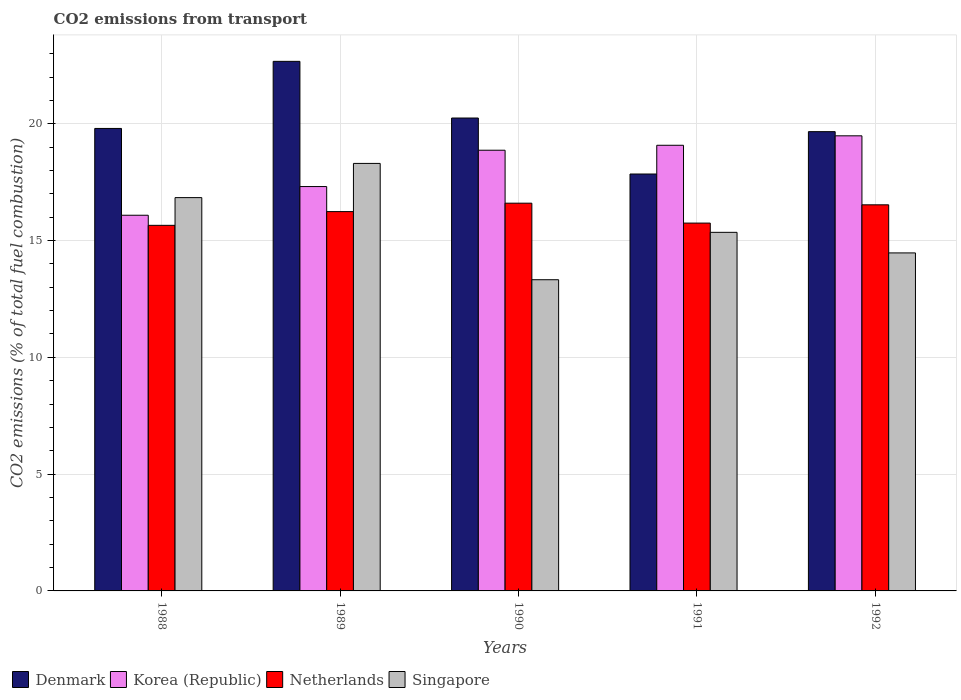How many different coloured bars are there?
Offer a very short reply. 4. How many groups of bars are there?
Your answer should be compact. 5. How many bars are there on the 1st tick from the right?
Ensure brevity in your answer.  4. What is the total CO2 emitted in Singapore in 1989?
Your answer should be compact. 18.3. Across all years, what is the maximum total CO2 emitted in Denmark?
Make the answer very short. 22.67. Across all years, what is the minimum total CO2 emitted in Korea (Republic)?
Your response must be concise. 16.08. In which year was the total CO2 emitted in Singapore minimum?
Keep it short and to the point. 1990. What is the total total CO2 emitted in Netherlands in the graph?
Keep it short and to the point. 80.76. What is the difference between the total CO2 emitted in Korea (Republic) in 1988 and that in 1991?
Offer a terse response. -3. What is the difference between the total CO2 emitted in Korea (Republic) in 1992 and the total CO2 emitted in Netherlands in 1991?
Offer a terse response. 3.74. What is the average total CO2 emitted in Singapore per year?
Ensure brevity in your answer.  15.66. In the year 1989, what is the difference between the total CO2 emitted in Denmark and total CO2 emitted in Singapore?
Make the answer very short. 4.37. In how many years, is the total CO2 emitted in Korea (Republic) greater than 21?
Provide a short and direct response. 0. What is the ratio of the total CO2 emitted in Singapore in 1991 to that in 1992?
Ensure brevity in your answer.  1.06. Is the difference between the total CO2 emitted in Denmark in 1989 and 1991 greater than the difference between the total CO2 emitted in Singapore in 1989 and 1991?
Your answer should be very brief. Yes. What is the difference between the highest and the second highest total CO2 emitted in Korea (Republic)?
Give a very brief answer. 0.4. What is the difference between the highest and the lowest total CO2 emitted in Korea (Republic)?
Give a very brief answer. 3.4. In how many years, is the total CO2 emitted in Denmark greater than the average total CO2 emitted in Denmark taken over all years?
Offer a very short reply. 2. Is it the case that in every year, the sum of the total CO2 emitted in Denmark and total CO2 emitted in Netherlands is greater than the sum of total CO2 emitted in Singapore and total CO2 emitted in Korea (Republic)?
Provide a short and direct response. No. What does the 1st bar from the right in 1991 represents?
Your response must be concise. Singapore. Is it the case that in every year, the sum of the total CO2 emitted in Netherlands and total CO2 emitted in Korea (Republic) is greater than the total CO2 emitted in Singapore?
Your response must be concise. Yes. How many bars are there?
Your answer should be compact. 20. What is the difference between two consecutive major ticks on the Y-axis?
Your answer should be very brief. 5. Does the graph contain grids?
Ensure brevity in your answer.  Yes. Where does the legend appear in the graph?
Offer a very short reply. Bottom left. How are the legend labels stacked?
Your answer should be very brief. Horizontal. What is the title of the graph?
Offer a terse response. CO2 emissions from transport. Does "Hungary" appear as one of the legend labels in the graph?
Your response must be concise. No. What is the label or title of the X-axis?
Offer a very short reply. Years. What is the label or title of the Y-axis?
Your response must be concise. CO2 emissions (% of total fuel combustion). What is the CO2 emissions (% of total fuel combustion) in Denmark in 1988?
Your answer should be compact. 19.8. What is the CO2 emissions (% of total fuel combustion) of Korea (Republic) in 1988?
Ensure brevity in your answer.  16.08. What is the CO2 emissions (% of total fuel combustion) of Netherlands in 1988?
Offer a terse response. 15.65. What is the CO2 emissions (% of total fuel combustion) of Singapore in 1988?
Ensure brevity in your answer.  16.84. What is the CO2 emissions (% of total fuel combustion) of Denmark in 1989?
Make the answer very short. 22.67. What is the CO2 emissions (% of total fuel combustion) of Korea (Republic) in 1989?
Ensure brevity in your answer.  17.31. What is the CO2 emissions (% of total fuel combustion) in Netherlands in 1989?
Give a very brief answer. 16.24. What is the CO2 emissions (% of total fuel combustion) in Singapore in 1989?
Provide a short and direct response. 18.3. What is the CO2 emissions (% of total fuel combustion) in Denmark in 1990?
Give a very brief answer. 20.24. What is the CO2 emissions (% of total fuel combustion) of Korea (Republic) in 1990?
Make the answer very short. 18.87. What is the CO2 emissions (% of total fuel combustion) in Netherlands in 1990?
Your answer should be very brief. 16.6. What is the CO2 emissions (% of total fuel combustion) of Singapore in 1990?
Offer a terse response. 13.32. What is the CO2 emissions (% of total fuel combustion) of Denmark in 1991?
Give a very brief answer. 17.85. What is the CO2 emissions (% of total fuel combustion) of Korea (Republic) in 1991?
Keep it short and to the point. 19.08. What is the CO2 emissions (% of total fuel combustion) in Netherlands in 1991?
Offer a terse response. 15.75. What is the CO2 emissions (% of total fuel combustion) of Singapore in 1991?
Provide a succinct answer. 15.35. What is the CO2 emissions (% of total fuel combustion) in Denmark in 1992?
Make the answer very short. 19.66. What is the CO2 emissions (% of total fuel combustion) of Korea (Republic) in 1992?
Offer a very short reply. 19.48. What is the CO2 emissions (% of total fuel combustion) of Netherlands in 1992?
Ensure brevity in your answer.  16.53. What is the CO2 emissions (% of total fuel combustion) in Singapore in 1992?
Offer a terse response. 14.47. Across all years, what is the maximum CO2 emissions (% of total fuel combustion) of Denmark?
Your response must be concise. 22.67. Across all years, what is the maximum CO2 emissions (% of total fuel combustion) in Korea (Republic)?
Provide a succinct answer. 19.48. Across all years, what is the maximum CO2 emissions (% of total fuel combustion) in Netherlands?
Keep it short and to the point. 16.6. Across all years, what is the maximum CO2 emissions (% of total fuel combustion) of Singapore?
Your answer should be compact. 18.3. Across all years, what is the minimum CO2 emissions (% of total fuel combustion) of Denmark?
Make the answer very short. 17.85. Across all years, what is the minimum CO2 emissions (% of total fuel combustion) in Korea (Republic)?
Make the answer very short. 16.08. Across all years, what is the minimum CO2 emissions (% of total fuel combustion) in Netherlands?
Your answer should be very brief. 15.65. Across all years, what is the minimum CO2 emissions (% of total fuel combustion) in Singapore?
Make the answer very short. 13.32. What is the total CO2 emissions (% of total fuel combustion) of Denmark in the graph?
Ensure brevity in your answer.  100.22. What is the total CO2 emissions (% of total fuel combustion) in Korea (Republic) in the graph?
Keep it short and to the point. 90.82. What is the total CO2 emissions (% of total fuel combustion) in Netherlands in the graph?
Offer a terse response. 80.76. What is the total CO2 emissions (% of total fuel combustion) of Singapore in the graph?
Ensure brevity in your answer.  78.28. What is the difference between the CO2 emissions (% of total fuel combustion) in Denmark in 1988 and that in 1989?
Your answer should be compact. -2.87. What is the difference between the CO2 emissions (% of total fuel combustion) in Korea (Republic) in 1988 and that in 1989?
Ensure brevity in your answer.  -1.23. What is the difference between the CO2 emissions (% of total fuel combustion) in Netherlands in 1988 and that in 1989?
Your answer should be compact. -0.59. What is the difference between the CO2 emissions (% of total fuel combustion) in Singapore in 1988 and that in 1989?
Provide a short and direct response. -1.46. What is the difference between the CO2 emissions (% of total fuel combustion) of Denmark in 1988 and that in 1990?
Your response must be concise. -0.45. What is the difference between the CO2 emissions (% of total fuel combustion) of Korea (Republic) in 1988 and that in 1990?
Offer a terse response. -2.78. What is the difference between the CO2 emissions (% of total fuel combustion) of Netherlands in 1988 and that in 1990?
Your response must be concise. -0.95. What is the difference between the CO2 emissions (% of total fuel combustion) of Singapore in 1988 and that in 1990?
Offer a very short reply. 3.51. What is the difference between the CO2 emissions (% of total fuel combustion) in Denmark in 1988 and that in 1991?
Make the answer very short. 1.95. What is the difference between the CO2 emissions (% of total fuel combustion) in Korea (Republic) in 1988 and that in 1991?
Ensure brevity in your answer.  -3. What is the difference between the CO2 emissions (% of total fuel combustion) of Netherlands in 1988 and that in 1991?
Your answer should be compact. -0.1. What is the difference between the CO2 emissions (% of total fuel combustion) of Singapore in 1988 and that in 1991?
Your response must be concise. 1.49. What is the difference between the CO2 emissions (% of total fuel combustion) of Denmark in 1988 and that in 1992?
Offer a terse response. 0.14. What is the difference between the CO2 emissions (% of total fuel combustion) in Korea (Republic) in 1988 and that in 1992?
Your answer should be very brief. -3.4. What is the difference between the CO2 emissions (% of total fuel combustion) of Netherlands in 1988 and that in 1992?
Offer a terse response. -0.88. What is the difference between the CO2 emissions (% of total fuel combustion) in Singapore in 1988 and that in 1992?
Give a very brief answer. 2.37. What is the difference between the CO2 emissions (% of total fuel combustion) of Denmark in 1989 and that in 1990?
Make the answer very short. 2.43. What is the difference between the CO2 emissions (% of total fuel combustion) of Korea (Republic) in 1989 and that in 1990?
Ensure brevity in your answer.  -1.56. What is the difference between the CO2 emissions (% of total fuel combustion) in Netherlands in 1989 and that in 1990?
Offer a terse response. -0.36. What is the difference between the CO2 emissions (% of total fuel combustion) of Singapore in 1989 and that in 1990?
Make the answer very short. 4.98. What is the difference between the CO2 emissions (% of total fuel combustion) in Denmark in 1989 and that in 1991?
Provide a succinct answer. 4.82. What is the difference between the CO2 emissions (% of total fuel combustion) of Korea (Republic) in 1989 and that in 1991?
Ensure brevity in your answer.  -1.77. What is the difference between the CO2 emissions (% of total fuel combustion) in Netherlands in 1989 and that in 1991?
Offer a very short reply. 0.49. What is the difference between the CO2 emissions (% of total fuel combustion) of Singapore in 1989 and that in 1991?
Offer a terse response. 2.95. What is the difference between the CO2 emissions (% of total fuel combustion) of Denmark in 1989 and that in 1992?
Your answer should be very brief. 3.01. What is the difference between the CO2 emissions (% of total fuel combustion) in Korea (Republic) in 1989 and that in 1992?
Offer a terse response. -2.17. What is the difference between the CO2 emissions (% of total fuel combustion) in Netherlands in 1989 and that in 1992?
Keep it short and to the point. -0.29. What is the difference between the CO2 emissions (% of total fuel combustion) of Singapore in 1989 and that in 1992?
Ensure brevity in your answer.  3.83. What is the difference between the CO2 emissions (% of total fuel combustion) of Denmark in 1990 and that in 1991?
Provide a succinct answer. 2.4. What is the difference between the CO2 emissions (% of total fuel combustion) in Korea (Republic) in 1990 and that in 1991?
Provide a short and direct response. -0.21. What is the difference between the CO2 emissions (% of total fuel combustion) of Netherlands in 1990 and that in 1991?
Your answer should be very brief. 0.85. What is the difference between the CO2 emissions (% of total fuel combustion) in Singapore in 1990 and that in 1991?
Keep it short and to the point. -2.03. What is the difference between the CO2 emissions (% of total fuel combustion) of Denmark in 1990 and that in 1992?
Make the answer very short. 0.58. What is the difference between the CO2 emissions (% of total fuel combustion) in Korea (Republic) in 1990 and that in 1992?
Your response must be concise. -0.62. What is the difference between the CO2 emissions (% of total fuel combustion) of Netherlands in 1990 and that in 1992?
Keep it short and to the point. 0.07. What is the difference between the CO2 emissions (% of total fuel combustion) of Singapore in 1990 and that in 1992?
Keep it short and to the point. -1.15. What is the difference between the CO2 emissions (% of total fuel combustion) of Denmark in 1991 and that in 1992?
Provide a short and direct response. -1.81. What is the difference between the CO2 emissions (% of total fuel combustion) of Korea (Republic) in 1991 and that in 1992?
Keep it short and to the point. -0.4. What is the difference between the CO2 emissions (% of total fuel combustion) of Netherlands in 1991 and that in 1992?
Offer a terse response. -0.78. What is the difference between the CO2 emissions (% of total fuel combustion) in Singapore in 1991 and that in 1992?
Ensure brevity in your answer.  0.88. What is the difference between the CO2 emissions (% of total fuel combustion) of Denmark in 1988 and the CO2 emissions (% of total fuel combustion) of Korea (Republic) in 1989?
Ensure brevity in your answer.  2.49. What is the difference between the CO2 emissions (% of total fuel combustion) of Denmark in 1988 and the CO2 emissions (% of total fuel combustion) of Netherlands in 1989?
Your response must be concise. 3.56. What is the difference between the CO2 emissions (% of total fuel combustion) of Denmark in 1988 and the CO2 emissions (% of total fuel combustion) of Singapore in 1989?
Keep it short and to the point. 1.5. What is the difference between the CO2 emissions (% of total fuel combustion) in Korea (Republic) in 1988 and the CO2 emissions (% of total fuel combustion) in Netherlands in 1989?
Your answer should be very brief. -0.16. What is the difference between the CO2 emissions (% of total fuel combustion) in Korea (Republic) in 1988 and the CO2 emissions (% of total fuel combustion) in Singapore in 1989?
Ensure brevity in your answer.  -2.22. What is the difference between the CO2 emissions (% of total fuel combustion) of Netherlands in 1988 and the CO2 emissions (% of total fuel combustion) of Singapore in 1989?
Offer a very short reply. -2.65. What is the difference between the CO2 emissions (% of total fuel combustion) in Denmark in 1988 and the CO2 emissions (% of total fuel combustion) in Korea (Republic) in 1990?
Your answer should be compact. 0.93. What is the difference between the CO2 emissions (% of total fuel combustion) in Denmark in 1988 and the CO2 emissions (% of total fuel combustion) in Netherlands in 1990?
Keep it short and to the point. 3.2. What is the difference between the CO2 emissions (% of total fuel combustion) in Denmark in 1988 and the CO2 emissions (% of total fuel combustion) in Singapore in 1990?
Your answer should be very brief. 6.48. What is the difference between the CO2 emissions (% of total fuel combustion) of Korea (Republic) in 1988 and the CO2 emissions (% of total fuel combustion) of Netherlands in 1990?
Your response must be concise. -0.52. What is the difference between the CO2 emissions (% of total fuel combustion) of Korea (Republic) in 1988 and the CO2 emissions (% of total fuel combustion) of Singapore in 1990?
Make the answer very short. 2.76. What is the difference between the CO2 emissions (% of total fuel combustion) in Netherlands in 1988 and the CO2 emissions (% of total fuel combustion) in Singapore in 1990?
Make the answer very short. 2.33. What is the difference between the CO2 emissions (% of total fuel combustion) in Denmark in 1988 and the CO2 emissions (% of total fuel combustion) in Korea (Republic) in 1991?
Your answer should be very brief. 0.72. What is the difference between the CO2 emissions (% of total fuel combustion) of Denmark in 1988 and the CO2 emissions (% of total fuel combustion) of Netherlands in 1991?
Make the answer very short. 4.05. What is the difference between the CO2 emissions (% of total fuel combustion) of Denmark in 1988 and the CO2 emissions (% of total fuel combustion) of Singapore in 1991?
Keep it short and to the point. 4.45. What is the difference between the CO2 emissions (% of total fuel combustion) in Korea (Republic) in 1988 and the CO2 emissions (% of total fuel combustion) in Netherlands in 1991?
Keep it short and to the point. 0.34. What is the difference between the CO2 emissions (% of total fuel combustion) in Korea (Republic) in 1988 and the CO2 emissions (% of total fuel combustion) in Singapore in 1991?
Your answer should be very brief. 0.73. What is the difference between the CO2 emissions (% of total fuel combustion) in Netherlands in 1988 and the CO2 emissions (% of total fuel combustion) in Singapore in 1991?
Your answer should be very brief. 0.3. What is the difference between the CO2 emissions (% of total fuel combustion) in Denmark in 1988 and the CO2 emissions (% of total fuel combustion) in Korea (Republic) in 1992?
Provide a succinct answer. 0.32. What is the difference between the CO2 emissions (% of total fuel combustion) of Denmark in 1988 and the CO2 emissions (% of total fuel combustion) of Netherlands in 1992?
Offer a terse response. 3.27. What is the difference between the CO2 emissions (% of total fuel combustion) in Denmark in 1988 and the CO2 emissions (% of total fuel combustion) in Singapore in 1992?
Keep it short and to the point. 5.33. What is the difference between the CO2 emissions (% of total fuel combustion) of Korea (Republic) in 1988 and the CO2 emissions (% of total fuel combustion) of Netherlands in 1992?
Offer a terse response. -0.45. What is the difference between the CO2 emissions (% of total fuel combustion) in Korea (Republic) in 1988 and the CO2 emissions (% of total fuel combustion) in Singapore in 1992?
Offer a very short reply. 1.61. What is the difference between the CO2 emissions (% of total fuel combustion) of Netherlands in 1988 and the CO2 emissions (% of total fuel combustion) of Singapore in 1992?
Offer a very short reply. 1.18. What is the difference between the CO2 emissions (% of total fuel combustion) of Denmark in 1989 and the CO2 emissions (% of total fuel combustion) of Korea (Republic) in 1990?
Offer a terse response. 3.8. What is the difference between the CO2 emissions (% of total fuel combustion) of Denmark in 1989 and the CO2 emissions (% of total fuel combustion) of Netherlands in 1990?
Provide a short and direct response. 6.07. What is the difference between the CO2 emissions (% of total fuel combustion) of Denmark in 1989 and the CO2 emissions (% of total fuel combustion) of Singapore in 1990?
Provide a short and direct response. 9.35. What is the difference between the CO2 emissions (% of total fuel combustion) of Korea (Republic) in 1989 and the CO2 emissions (% of total fuel combustion) of Netherlands in 1990?
Ensure brevity in your answer.  0.71. What is the difference between the CO2 emissions (% of total fuel combustion) of Korea (Republic) in 1989 and the CO2 emissions (% of total fuel combustion) of Singapore in 1990?
Give a very brief answer. 3.99. What is the difference between the CO2 emissions (% of total fuel combustion) in Netherlands in 1989 and the CO2 emissions (% of total fuel combustion) in Singapore in 1990?
Give a very brief answer. 2.92. What is the difference between the CO2 emissions (% of total fuel combustion) in Denmark in 1989 and the CO2 emissions (% of total fuel combustion) in Korea (Republic) in 1991?
Make the answer very short. 3.59. What is the difference between the CO2 emissions (% of total fuel combustion) of Denmark in 1989 and the CO2 emissions (% of total fuel combustion) of Netherlands in 1991?
Your answer should be very brief. 6.92. What is the difference between the CO2 emissions (% of total fuel combustion) of Denmark in 1989 and the CO2 emissions (% of total fuel combustion) of Singapore in 1991?
Your answer should be very brief. 7.32. What is the difference between the CO2 emissions (% of total fuel combustion) in Korea (Republic) in 1989 and the CO2 emissions (% of total fuel combustion) in Netherlands in 1991?
Your answer should be very brief. 1.56. What is the difference between the CO2 emissions (% of total fuel combustion) in Korea (Republic) in 1989 and the CO2 emissions (% of total fuel combustion) in Singapore in 1991?
Provide a succinct answer. 1.96. What is the difference between the CO2 emissions (% of total fuel combustion) of Netherlands in 1989 and the CO2 emissions (% of total fuel combustion) of Singapore in 1991?
Provide a succinct answer. 0.89. What is the difference between the CO2 emissions (% of total fuel combustion) of Denmark in 1989 and the CO2 emissions (% of total fuel combustion) of Korea (Republic) in 1992?
Offer a very short reply. 3.19. What is the difference between the CO2 emissions (% of total fuel combustion) of Denmark in 1989 and the CO2 emissions (% of total fuel combustion) of Netherlands in 1992?
Make the answer very short. 6.14. What is the difference between the CO2 emissions (% of total fuel combustion) in Denmark in 1989 and the CO2 emissions (% of total fuel combustion) in Singapore in 1992?
Your answer should be very brief. 8.2. What is the difference between the CO2 emissions (% of total fuel combustion) of Korea (Republic) in 1989 and the CO2 emissions (% of total fuel combustion) of Netherlands in 1992?
Give a very brief answer. 0.78. What is the difference between the CO2 emissions (% of total fuel combustion) in Korea (Republic) in 1989 and the CO2 emissions (% of total fuel combustion) in Singapore in 1992?
Give a very brief answer. 2.84. What is the difference between the CO2 emissions (% of total fuel combustion) of Netherlands in 1989 and the CO2 emissions (% of total fuel combustion) of Singapore in 1992?
Keep it short and to the point. 1.77. What is the difference between the CO2 emissions (% of total fuel combustion) in Denmark in 1990 and the CO2 emissions (% of total fuel combustion) in Korea (Republic) in 1991?
Offer a very short reply. 1.17. What is the difference between the CO2 emissions (% of total fuel combustion) in Denmark in 1990 and the CO2 emissions (% of total fuel combustion) in Netherlands in 1991?
Provide a short and direct response. 4.5. What is the difference between the CO2 emissions (% of total fuel combustion) of Denmark in 1990 and the CO2 emissions (% of total fuel combustion) of Singapore in 1991?
Offer a terse response. 4.89. What is the difference between the CO2 emissions (% of total fuel combustion) in Korea (Republic) in 1990 and the CO2 emissions (% of total fuel combustion) in Netherlands in 1991?
Ensure brevity in your answer.  3.12. What is the difference between the CO2 emissions (% of total fuel combustion) in Korea (Republic) in 1990 and the CO2 emissions (% of total fuel combustion) in Singapore in 1991?
Your answer should be very brief. 3.52. What is the difference between the CO2 emissions (% of total fuel combustion) in Netherlands in 1990 and the CO2 emissions (% of total fuel combustion) in Singapore in 1991?
Offer a very short reply. 1.25. What is the difference between the CO2 emissions (% of total fuel combustion) in Denmark in 1990 and the CO2 emissions (% of total fuel combustion) in Korea (Republic) in 1992?
Keep it short and to the point. 0.76. What is the difference between the CO2 emissions (% of total fuel combustion) of Denmark in 1990 and the CO2 emissions (% of total fuel combustion) of Netherlands in 1992?
Provide a succinct answer. 3.72. What is the difference between the CO2 emissions (% of total fuel combustion) of Denmark in 1990 and the CO2 emissions (% of total fuel combustion) of Singapore in 1992?
Your response must be concise. 5.77. What is the difference between the CO2 emissions (% of total fuel combustion) of Korea (Republic) in 1990 and the CO2 emissions (% of total fuel combustion) of Netherlands in 1992?
Your answer should be very brief. 2.34. What is the difference between the CO2 emissions (% of total fuel combustion) in Korea (Republic) in 1990 and the CO2 emissions (% of total fuel combustion) in Singapore in 1992?
Make the answer very short. 4.4. What is the difference between the CO2 emissions (% of total fuel combustion) in Netherlands in 1990 and the CO2 emissions (% of total fuel combustion) in Singapore in 1992?
Give a very brief answer. 2.13. What is the difference between the CO2 emissions (% of total fuel combustion) in Denmark in 1991 and the CO2 emissions (% of total fuel combustion) in Korea (Republic) in 1992?
Provide a succinct answer. -1.64. What is the difference between the CO2 emissions (% of total fuel combustion) of Denmark in 1991 and the CO2 emissions (% of total fuel combustion) of Netherlands in 1992?
Provide a short and direct response. 1.32. What is the difference between the CO2 emissions (% of total fuel combustion) of Denmark in 1991 and the CO2 emissions (% of total fuel combustion) of Singapore in 1992?
Give a very brief answer. 3.38. What is the difference between the CO2 emissions (% of total fuel combustion) of Korea (Republic) in 1991 and the CO2 emissions (% of total fuel combustion) of Netherlands in 1992?
Provide a succinct answer. 2.55. What is the difference between the CO2 emissions (% of total fuel combustion) of Korea (Republic) in 1991 and the CO2 emissions (% of total fuel combustion) of Singapore in 1992?
Offer a terse response. 4.61. What is the difference between the CO2 emissions (% of total fuel combustion) in Netherlands in 1991 and the CO2 emissions (% of total fuel combustion) in Singapore in 1992?
Offer a terse response. 1.28. What is the average CO2 emissions (% of total fuel combustion) of Denmark per year?
Provide a succinct answer. 20.04. What is the average CO2 emissions (% of total fuel combustion) of Korea (Republic) per year?
Provide a succinct answer. 18.16. What is the average CO2 emissions (% of total fuel combustion) of Netherlands per year?
Your answer should be compact. 16.15. What is the average CO2 emissions (% of total fuel combustion) in Singapore per year?
Provide a succinct answer. 15.66. In the year 1988, what is the difference between the CO2 emissions (% of total fuel combustion) in Denmark and CO2 emissions (% of total fuel combustion) in Korea (Republic)?
Your answer should be very brief. 3.72. In the year 1988, what is the difference between the CO2 emissions (% of total fuel combustion) of Denmark and CO2 emissions (% of total fuel combustion) of Netherlands?
Your answer should be compact. 4.15. In the year 1988, what is the difference between the CO2 emissions (% of total fuel combustion) of Denmark and CO2 emissions (% of total fuel combustion) of Singapore?
Offer a very short reply. 2.96. In the year 1988, what is the difference between the CO2 emissions (% of total fuel combustion) in Korea (Republic) and CO2 emissions (% of total fuel combustion) in Netherlands?
Provide a short and direct response. 0.43. In the year 1988, what is the difference between the CO2 emissions (% of total fuel combustion) in Korea (Republic) and CO2 emissions (% of total fuel combustion) in Singapore?
Your answer should be compact. -0.75. In the year 1988, what is the difference between the CO2 emissions (% of total fuel combustion) in Netherlands and CO2 emissions (% of total fuel combustion) in Singapore?
Your answer should be compact. -1.19. In the year 1989, what is the difference between the CO2 emissions (% of total fuel combustion) in Denmark and CO2 emissions (% of total fuel combustion) in Korea (Republic)?
Your answer should be very brief. 5.36. In the year 1989, what is the difference between the CO2 emissions (% of total fuel combustion) of Denmark and CO2 emissions (% of total fuel combustion) of Netherlands?
Your answer should be very brief. 6.43. In the year 1989, what is the difference between the CO2 emissions (% of total fuel combustion) in Denmark and CO2 emissions (% of total fuel combustion) in Singapore?
Your response must be concise. 4.37. In the year 1989, what is the difference between the CO2 emissions (% of total fuel combustion) in Korea (Republic) and CO2 emissions (% of total fuel combustion) in Netherlands?
Offer a very short reply. 1.07. In the year 1989, what is the difference between the CO2 emissions (% of total fuel combustion) of Korea (Republic) and CO2 emissions (% of total fuel combustion) of Singapore?
Provide a short and direct response. -0.99. In the year 1989, what is the difference between the CO2 emissions (% of total fuel combustion) in Netherlands and CO2 emissions (% of total fuel combustion) in Singapore?
Keep it short and to the point. -2.06. In the year 1990, what is the difference between the CO2 emissions (% of total fuel combustion) of Denmark and CO2 emissions (% of total fuel combustion) of Korea (Republic)?
Ensure brevity in your answer.  1.38. In the year 1990, what is the difference between the CO2 emissions (% of total fuel combustion) in Denmark and CO2 emissions (% of total fuel combustion) in Netherlands?
Make the answer very short. 3.65. In the year 1990, what is the difference between the CO2 emissions (% of total fuel combustion) of Denmark and CO2 emissions (% of total fuel combustion) of Singapore?
Provide a succinct answer. 6.92. In the year 1990, what is the difference between the CO2 emissions (% of total fuel combustion) in Korea (Republic) and CO2 emissions (% of total fuel combustion) in Netherlands?
Offer a very short reply. 2.27. In the year 1990, what is the difference between the CO2 emissions (% of total fuel combustion) in Korea (Republic) and CO2 emissions (% of total fuel combustion) in Singapore?
Keep it short and to the point. 5.54. In the year 1990, what is the difference between the CO2 emissions (% of total fuel combustion) of Netherlands and CO2 emissions (% of total fuel combustion) of Singapore?
Provide a succinct answer. 3.28. In the year 1991, what is the difference between the CO2 emissions (% of total fuel combustion) in Denmark and CO2 emissions (% of total fuel combustion) in Korea (Republic)?
Your answer should be very brief. -1.23. In the year 1991, what is the difference between the CO2 emissions (% of total fuel combustion) in Denmark and CO2 emissions (% of total fuel combustion) in Netherlands?
Provide a short and direct response. 2.1. In the year 1991, what is the difference between the CO2 emissions (% of total fuel combustion) in Denmark and CO2 emissions (% of total fuel combustion) in Singapore?
Provide a succinct answer. 2.5. In the year 1991, what is the difference between the CO2 emissions (% of total fuel combustion) in Korea (Republic) and CO2 emissions (% of total fuel combustion) in Netherlands?
Keep it short and to the point. 3.33. In the year 1991, what is the difference between the CO2 emissions (% of total fuel combustion) of Korea (Republic) and CO2 emissions (% of total fuel combustion) of Singapore?
Make the answer very short. 3.73. In the year 1991, what is the difference between the CO2 emissions (% of total fuel combustion) of Netherlands and CO2 emissions (% of total fuel combustion) of Singapore?
Provide a short and direct response. 0.4. In the year 1992, what is the difference between the CO2 emissions (% of total fuel combustion) of Denmark and CO2 emissions (% of total fuel combustion) of Korea (Republic)?
Provide a short and direct response. 0.18. In the year 1992, what is the difference between the CO2 emissions (% of total fuel combustion) in Denmark and CO2 emissions (% of total fuel combustion) in Netherlands?
Provide a succinct answer. 3.13. In the year 1992, what is the difference between the CO2 emissions (% of total fuel combustion) in Denmark and CO2 emissions (% of total fuel combustion) in Singapore?
Offer a terse response. 5.19. In the year 1992, what is the difference between the CO2 emissions (% of total fuel combustion) of Korea (Republic) and CO2 emissions (% of total fuel combustion) of Netherlands?
Provide a succinct answer. 2.95. In the year 1992, what is the difference between the CO2 emissions (% of total fuel combustion) of Korea (Republic) and CO2 emissions (% of total fuel combustion) of Singapore?
Offer a terse response. 5.01. In the year 1992, what is the difference between the CO2 emissions (% of total fuel combustion) of Netherlands and CO2 emissions (% of total fuel combustion) of Singapore?
Keep it short and to the point. 2.06. What is the ratio of the CO2 emissions (% of total fuel combustion) of Denmark in 1988 to that in 1989?
Your answer should be very brief. 0.87. What is the ratio of the CO2 emissions (% of total fuel combustion) in Korea (Republic) in 1988 to that in 1989?
Ensure brevity in your answer.  0.93. What is the ratio of the CO2 emissions (% of total fuel combustion) of Netherlands in 1988 to that in 1989?
Your response must be concise. 0.96. What is the ratio of the CO2 emissions (% of total fuel combustion) in Denmark in 1988 to that in 1990?
Provide a short and direct response. 0.98. What is the ratio of the CO2 emissions (% of total fuel combustion) in Korea (Republic) in 1988 to that in 1990?
Offer a very short reply. 0.85. What is the ratio of the CO2 emissions (% of total fuel combustion) in Netherlands in 1988 to that in 1990?
Your response must be concise. 0.94. What is the ratio of the CO2 emissions (% of total fuel combustion) in Singapore in 1988 to that in 1990?
Keep it short and to the point. 1.26. What is the ratio of the CO2 emissions (% of total fuel combustion) of Denmark in 1988 to that in 1991?
Ensure brevity in your answer.  1.11. What is the ratio of the CO2 emissions (% of total fuel combustion) of Korea (Republic) in 1988 to that in 1991?
Offer a terse response. 0.84. What is the ratio of the CO2 emissions (% of total fuel combustion) in Singapore in 1988 to that in 1991?
Ensure brevity in your answer.  1.1. What is the ratio of the CO2 emissions (% of total fuel combustion) in Korea (Republic) in 1988 to that in 1992?
Ensure brevity in your answer.  0.83. What is the ratio of the CO2 emissions (% of total fuel combustion) of Netherlands in 1988 to that in 1992?
Your response must be concise. 0.95. What is the ratio of the CO2 emissions (% of total fuel combustion) in Singapore in 1988 to that in 1992?
Provide a succinct answer. 1.16. What is the ratio of the CO2 emissions (% of total fuel combustion) in Denmark in 1989 to that in 1990?
Make the answer very short. 1.12. What is the ratio of the CO2 emissions (% of total fuel combustion) in Korea (Republic) in 1989 to that in 1990?
Your response must be concise. 0.92. What is the ratio of the CO2 emissions (% of total fuel combustion) in Netherlands in 1989 to that in 1990?
Your answer should be very brief. 0.98. What is the ratio of the CO2 emissions (% of total fuel combustion) in Singapore in 1989 to that in 1990?
Your response must be concise. 1.37. What is the ratio of the CO2 emissions (% of total fuel combustion) of Denmark in 1989 to that in 1991?
Make the answer very short. 1.27. What is the ratio of the CO2 emissions (% of total fuel combustion) in Korea (Republic) in 1989 to that in 1991?
Your answer should be very brief. 0.91. What is the ratio of the CO2 emissions (% of total fuel combustion) of Netherlands in 1989 to that in 1991?
Make the answer very short. 1.03. What is the ratio of the CO2 emissions (% of total fuel combustion) of Singapore in 1989 to that in 1991?
Provide a succinct answer. 1.19. What is the ratio of the CO2 emissions (% of total fuel combustion) of Denmark in 1989 to that in 1992?
Offer a very short reply. 1.15. What is the ratio of the CO2 emissions (% of total fuel combustion) in Korea (Republic) in 1989 to that in 1992?
Provide a succinct answer. 0.89. What is the ratio of the CO2 emissions (% of total fuel combustion) of Netherlands in 1989 to that in 1992?
Your answer should be compact. 0.98. What is the ratio of the CO2 emissions (% of total fuel combustion) of Singapore in 1989 to that in 1992?
Your response must be concise. 1.26. What is the ratio of the CO2 emissions (% of total fuel combustion) in Denmark in 1990 to that in 1991?
Offer a very short reply. 1.13. What is the ratio of the CO2 emissions (% of total fuel combustion) of Korea (Republic) in 1990 to that in 1991?
Make the answer very short. 0.99. What is the ratio of the CO2 emissions (% of total fuel combustion) in Netherlands in 1990 to that in 1991?
Your answer should be very brief. 1.05. What is the ratio of the CO2 emissions (% of total fuel combustion) of Singapore in 1990 to that in 1991?
Your response must be concise. 0.87. What is the ratio of the CO2 emissions (% of total fuel combustion) of Denmark in 1990 to that in 1992?
Provide a succinct answer. 1.03. What is the ratio of the CO2 emissions (% of total fuel combustion) of Korea (Republic) in 1990 to that in 1992?
Keep it short and to the point. 0.97. What is the ratio of the CO2 emissions (% of total fuel combustion) of Singapore in 1990 to that in 1992?
Ensure brevity in your answer.  0.92. What is the ratio of the CO2 emissions (% of total fuel combustion) of Denmark in 1991 to that in 1992?
Keep it short and to the point. 0.91. What is the ratio of the CO2 emissions (% of total fuel combustion) in Korea (Republic) in 1991 to that in 1992?
Give a very brief answer. 0.98. What is the ratio of the CO2 emissions (% of total fuel combustion) in Netherlands in 1991 to that in 1992?
Your answer should be compact. 0.95. What is the ratio of the CO2 emissions (% of total fuel combustion) in Singapore in 1991 to that in 1992?
Make the answer very short. 1.06. What is the difference between the highest and the second highest CO2 emissions (% of total fuel combustion) of Denmark?
Give a very brief answer. 2.43. What is the difference between the highest and the second highest CO2 emissions (% of total fuel combustion) of Korea (Republic)?
Provide a succinct answer. 0.4. What is the difference between the highest and the second highest CO2 emissions (% of total fuel combustion) in Netherlands?
Offer a very short reply. 0.07. What is the difference between the highest and the second highest CO2 emissions (% of total fuel combustion) of Singapore?
Offer a terse response. 1.46. What is the difference between the highest and the lowest CO2 emissions (% of total fuel combustion) in Denmark?
Offer a terse response. 4.82. What is the difference between the highest and the lowest CO2 emissions (% of total fuel combustion) of Korea (Republic)?
Provide a succinct answer. 3.4. What is the difference between the highest and the lowest CO2 emissions (% of total fuel combustion) in Netherlands?
Your response must be concise. 0.95. What is the difference between the highest and the lowest CO2 emissions (% of total fuel combustion) in Singapore?
Make the answer very short. 4.98. 